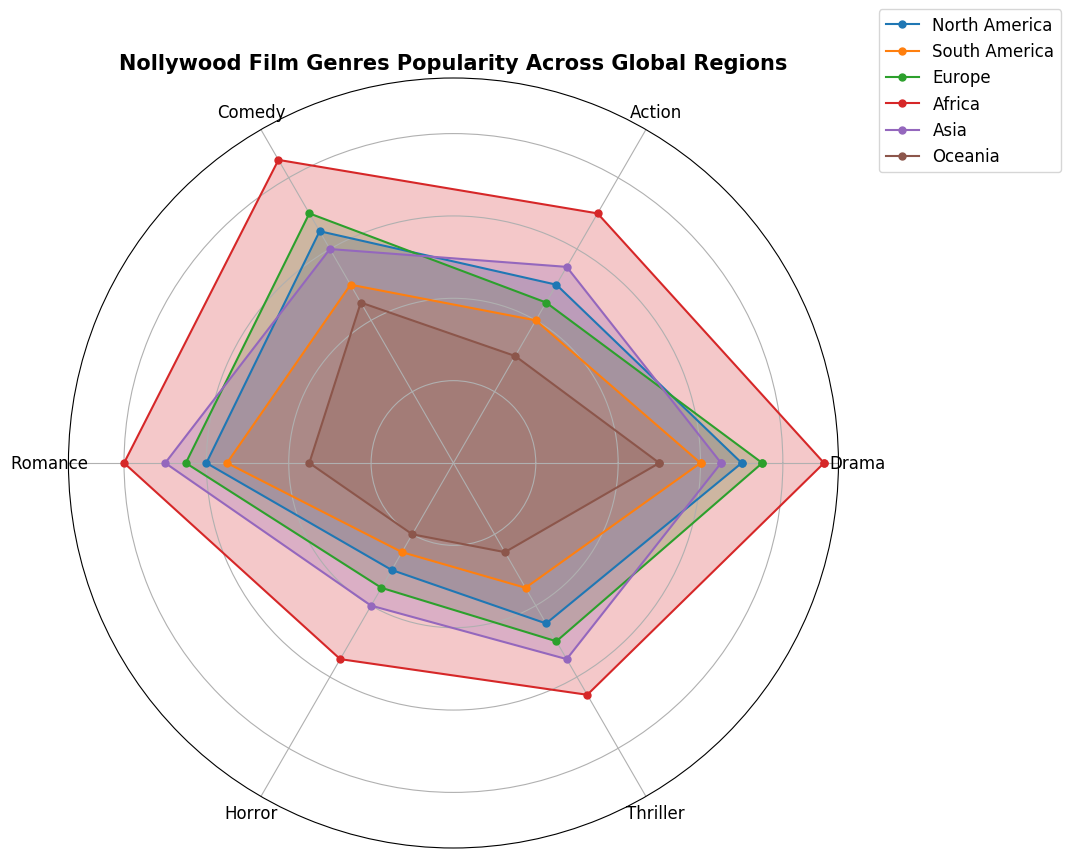Which region shows the highest popularity for Drama? To determine the region with the highest popularity for Drama, look at the Drama values across all regions. Africa has a Drama popularity of 90, which is the highest.
Answer: Africa Which genre has the lowest popularity in Oceania? To find the genre with the lowest popularity in Oceania, look at Oceania's values for all genres. Horror has the lowest value at 20.
Answer: Horror How does the popularity of Comedy in Europe compare with Comedy in Africa? Compare the Comedy values for Europe and Africa. Europe has a Comedy value of 70, while Africa has a value of 85. Therefore, Comedy is less popular in Europe than in Africa.
Answer: Less popular What’s the average popularity of Romance across all the regions? Add up the Romance values for all regions and divide by the number of regions: (60 + 55 + 65 + 80 + 70 + 35) / 6. The sum is 365, so the average is 365 / 6, approximately 60.83.
Answer: 60.83 In which region is the difference between Action and Thriller the greatest? Calculate the difference between Action and Thriller for each region and find the maximum: North America (50-45=5), South America (40-35=5), Europe (45-50=5), Africa (70-65=5), Asia (55-55=0), Oceania (30-25=5). All are 5 except Asia, where the difference is 0. Hence there’s a tie among several regions with a maximum difference of 5.
Answer: Tie: North America, South America, Europe, Africa, Oceania Which regions have equal popularity for Thriller and Horror genres? Compare the Thriller and Horror values for each region: North America (45 vs 30), South America (35 vs 25), Europe (50 vs 35), Africa (65 vs 55), Asia (55 vs 40), Oceania (25 vs 20). In all regions, the values for Thriller and Horror are different.
Answer: None Which genre is the most popular in South America? Look at the values for each genre in South America and find the highest. Drama has the highest popularity with a value of 60.
Answer: Drama How does the popularity of Horror in Asia compare with Romance in Oceania? Compare the values for Horror in Asia (40) and Romance in Oceania (35). Horror in Asia is more popular than Romance in Oceania.
Answer: Horror in Asia is more popular What is the sum of popularity values of Action and Comedy in North America? Sum the values of Action and Comedy in North America: 50 + 65 = 115.
Answer: 115 Which region has the lowest popularity for Drama, and what is the value? Compare the Drama values across all regions to find the lowest. Oceania has the lowest Drama popularity with a value of 50.
Answer: Oceania, 50 